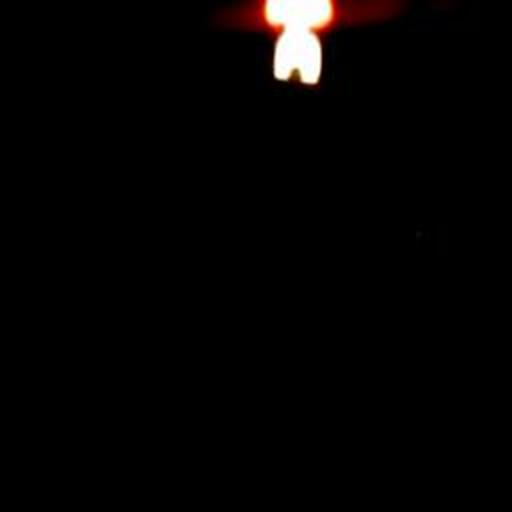Can you describe the mood or atmosphere this image might convey? The image exudes a mysterious or solemn atmosphere, potentially evoking feelings of introspection or tranquility in the viewer due to the contrast between the light and dark areas. 